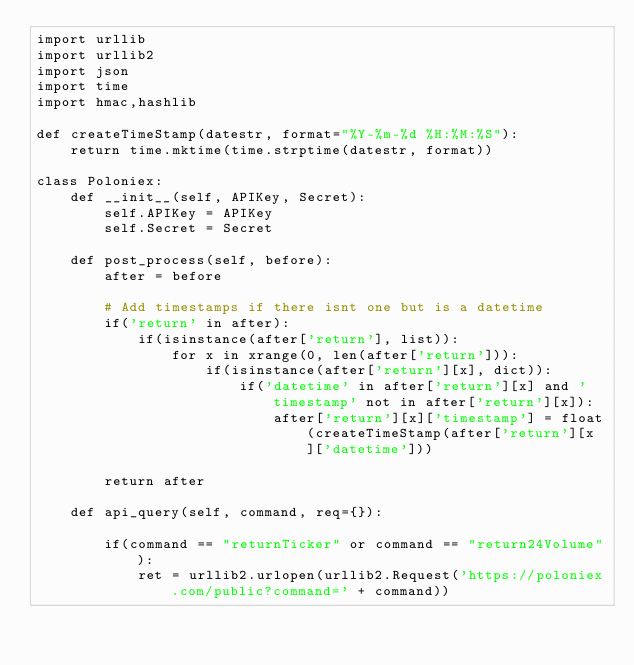Convert code to text. <code><loc_0><loc_0><loc_500><loc_500><_Python_>import urllib
import urllib2
import json
import time
import hmac,hashlib

def createTimeStamp(datestr, format="%Y-%m-%d %H:%M:%S"):
    return time.mktime(time.strptime(datestr, format))

class Poloniex:
    def __init__(self, APIKey, Secret):
        self.APIKey = APIKey
        self.Secret = Secret

    def post_process(self, before):
        after = before

        # Add timestamps if there isnt one but is a datetime
        if('return' in after):
            if(isinstance(after['return'], list)):
                for x in xrange(0, len(after['return'])):
                    if(isinstance(after['return'][x], dict)):
                        if('datetime' in after['return'][x] and 'timestamp' not in after['return'][x]):
                            after['return'][x]['timestamp'] = float(createTimeStamp(after['return'][x]['datetime']))
                            
        return after

    def api_query(self, command, req={}):

        if(command == "returnTicker" or command == "return24Volume"):
            ret = urllib2.urlopen(urllib2.Request('https://poloniex.com/public?command=' + command))</code> 